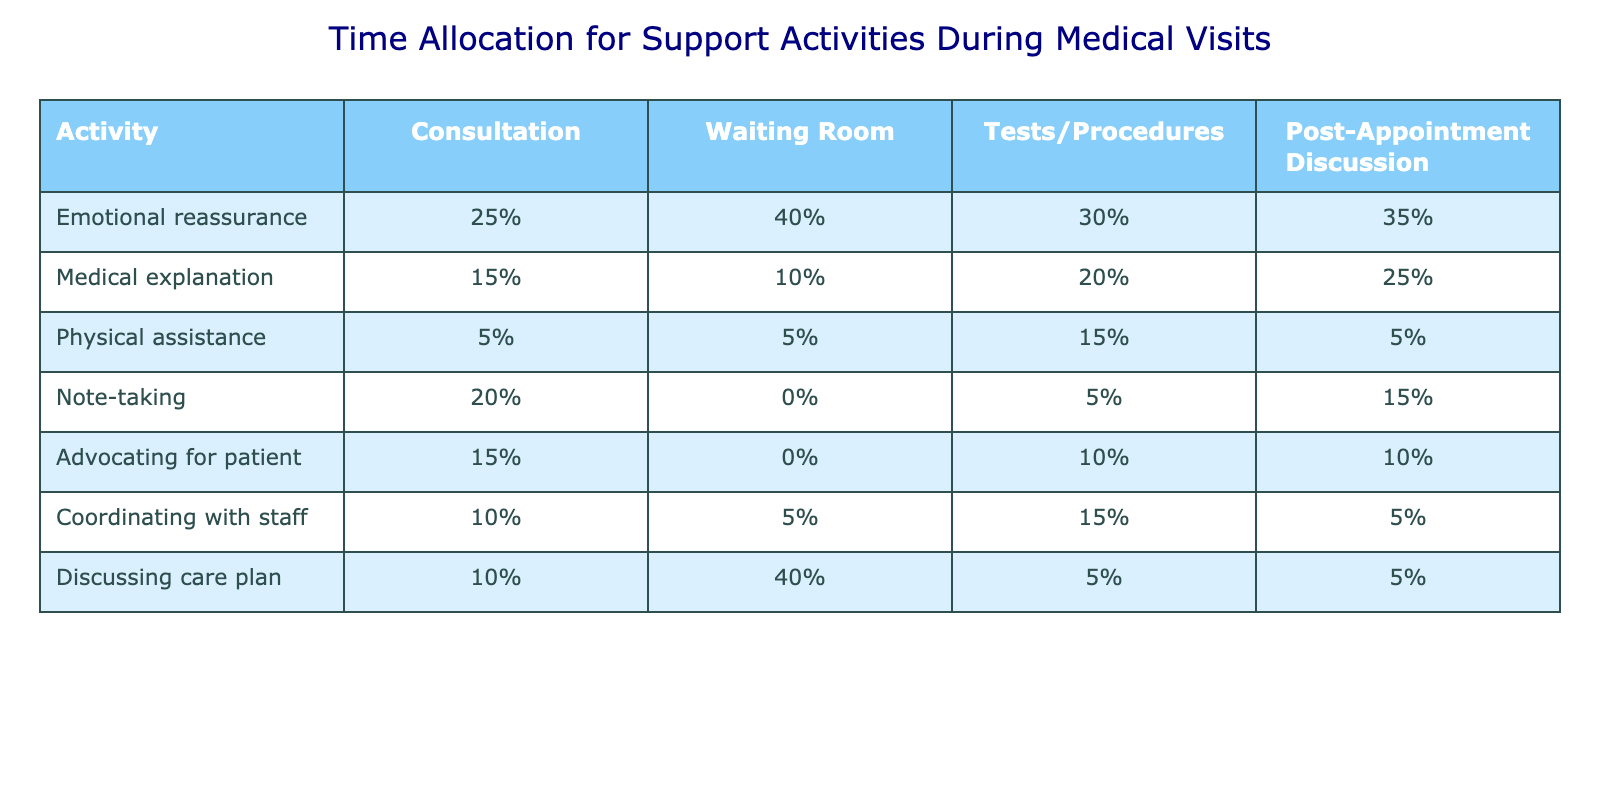What percentage of time is allocated to emotional reassurance during consultations? The table indicates that emotional reassurance takes up 25% of the total time allocated during consultations, as shown in the corresponding row under the Consultation column.
Answer: 25% What is the total percentage of time spent on medical explanation during waiting room activities and post-appointment discussions? For waiting room activities, medical explanation occupies 10%, and for post-appointment discussions, it occupies 25%. Adding these together gives 10% + 25% = 35%.
Answer: 35% Is physical assistance prioritized more during tests/procedures than during post-appointment discussions? The table shows that physical assistance takes up 15% during tests/procedures and only 5% during post-appointment discussions. Since 15% is greater than 5%, physical assistance is indeed prioritized more during tests/procedures.
Answer: Yes What is the average percentage of time spent on note-taking across all activities? The percentages for note-taking are 20%, 0%, 5%, and 15% across the four activities. Adding them gives 20% + 0% + 5% + 15% = 40%, and dividing by 4 activities gives an average of 40% / 4 = 10%.
Answer: 10% Which support activity has the highest percentage during consultations? Looking at the percentages for all activities during consultations, emotional reassurance (25%) has the highest value, compared to medical explanation (15%), physical assistance (5%), note-taking (20%), advocating for patient (15%), coordinating with staff (10%), and discussing care plan (10%).
Answer: Emotional reassurance What is the total percentage of time dedicated to advocating for the patient across all activities? The advocating for patient percentages are 15% (Consultation), 0% (Waiting Room), 10% (Tests/Procedures), and 10% (Post-Appointment Discussion). Adding them gives 15% + 0% + 10% + 10% = 35%.
Answer: 35% During which activity is the coordination with staff the highest? The table shows that coordination with staff is 10% during consultations, 5% during the waiting room, 15% during tests/procedures, and 5% during post-appointment discussions. The highest percentage is 15% during tests/procedures.
Answer: Tests/Procedures If we compare the time allocated for discussing the care plan during waiting room and post-appointment, how much more is allocated to waiting room activities? Discussing the care plan is 40% in the waiting room and 5% post-appointment. The difference is 40% - 5% = 35%, indicating more time is allocated during waiting room activities.
Answer: 35% Which activity experiences the least amount of time allocated for emotional reassurance? The table shows emotional reassurance is 25% for consultations, 40% for waiting room, 30% for tests/procedures, and 35% for post-appointment discussions. The least amount occurs during consultations at 25%.
Answer: Consultations 